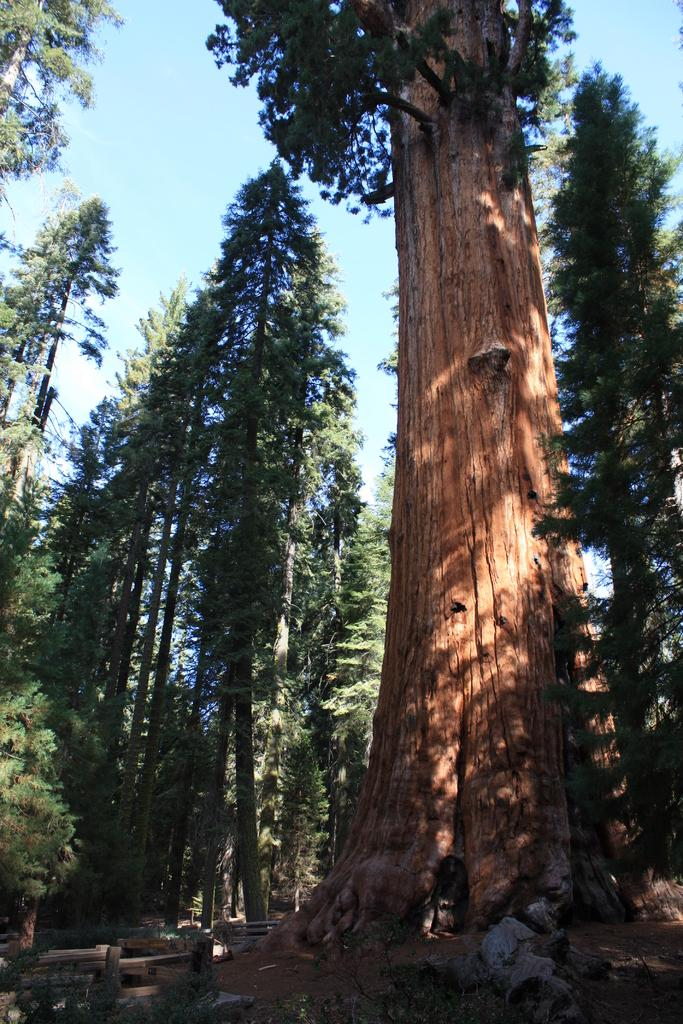What type of vegetation can be seen in the image? There are trees in the image. What colors are the trees in the image? The trees are green and brown in color. What else is present on the ground in the image? There is grass and other objects on the ground. What can be seen in the background of the image? The sky is visible in the background of the image. Where is the brother in the image? There is no brother present in the image. What type of wheel can be seen in the image? There is no wheel present in the image. 